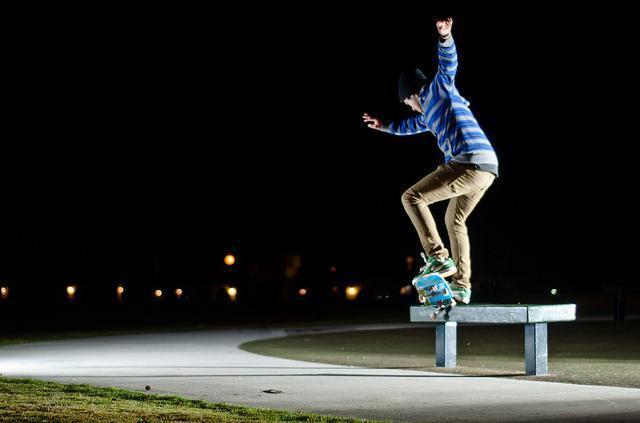How many people in this image are dragging a suitcase behind them?
Give a very brief answer. 0. 